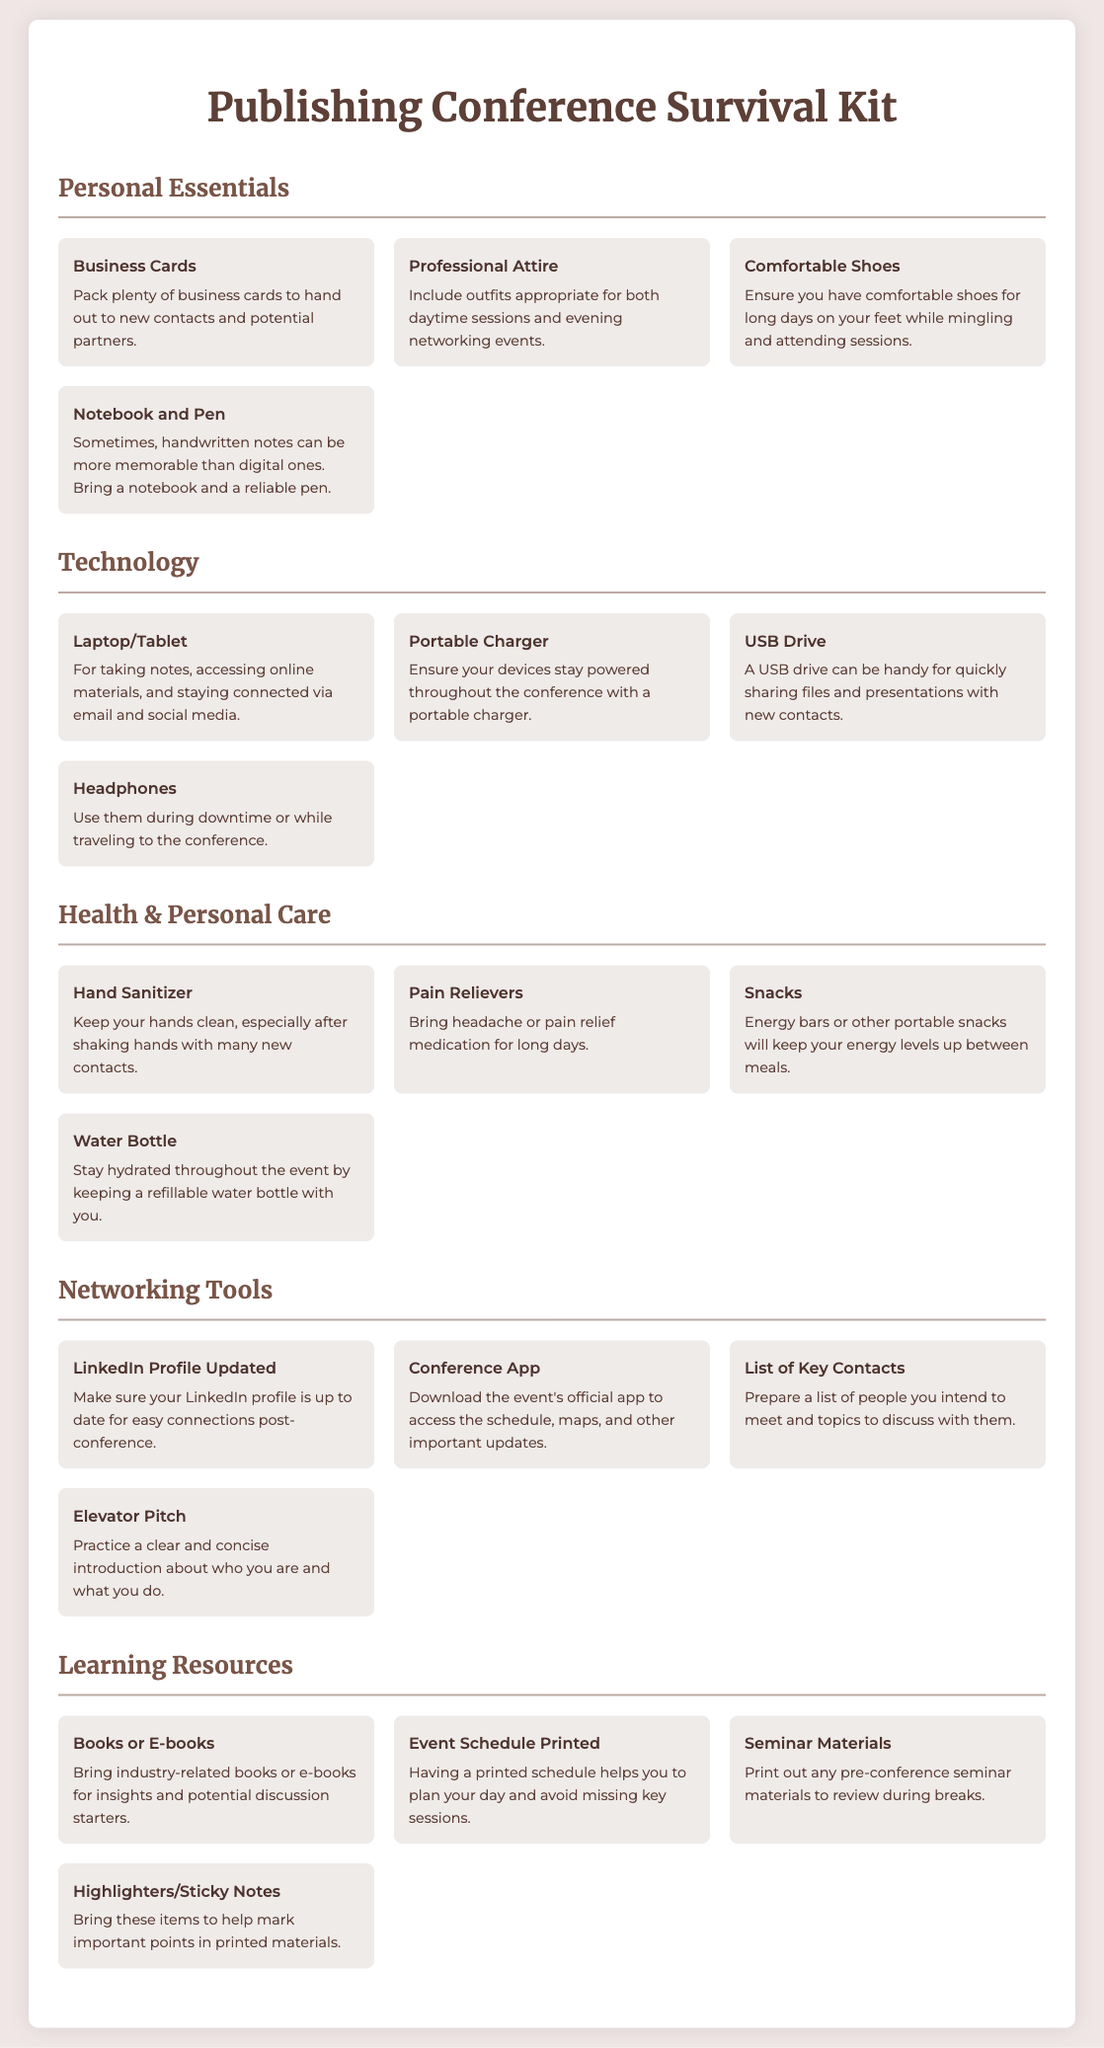What items are categorized under "Personal Essentials"? The items listed under "Personal Essentials" include Business Cards, Professional Attire, Comfortable Shoes, and Notebook and Pen.
Answer: Business Cards, Professional Attire, Comfortable Shoes, Notebook and Pen How many items are in the "Technology" category? The "Technology" category contains four items listed: Laptop/Tablet, Portable Charger, USB Drive, and Headphones.
Answer: 4 What should you bring for hydration during the conference? The document mentions bringing a Water Bottle for hydration throughout the event.
Answer: Water Bottle What is a recommended preparation for your LinkedIn profile? The document advises ensuring that your LinkedIn profile is updated for easy connections post-conference.
Answer: Updated Which item is suggested for marking important points in printed materials? Highlighters and Sticky Notes are suggested for marking important points in printed materials.
Answer: Highlighters/Sticky Notes What type of business attire should be included in the packing list? The document suggests including outfits appropriate for both daytime sessions and evening networking events.
Answer: Professional Attire 